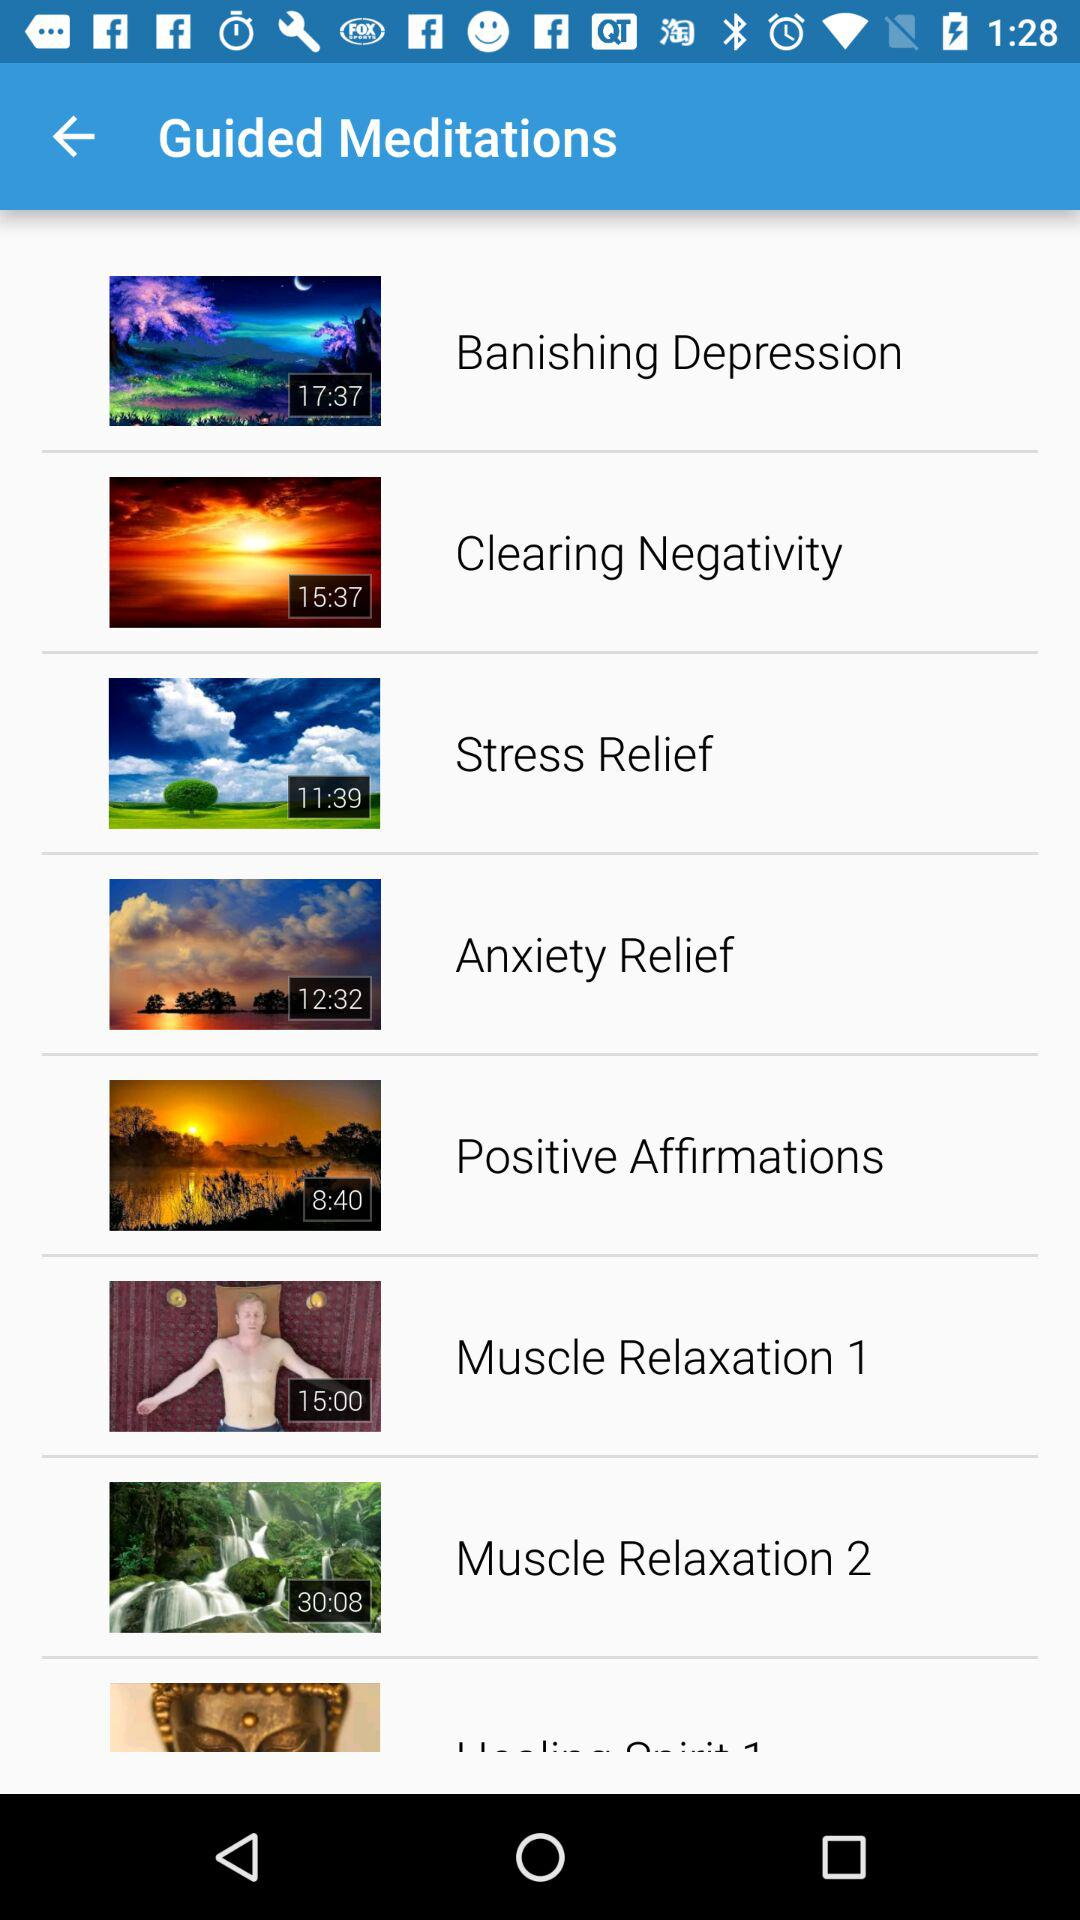What is the duration of the video "Banishing Depression" meditation? The duration of the video is 17:37. 